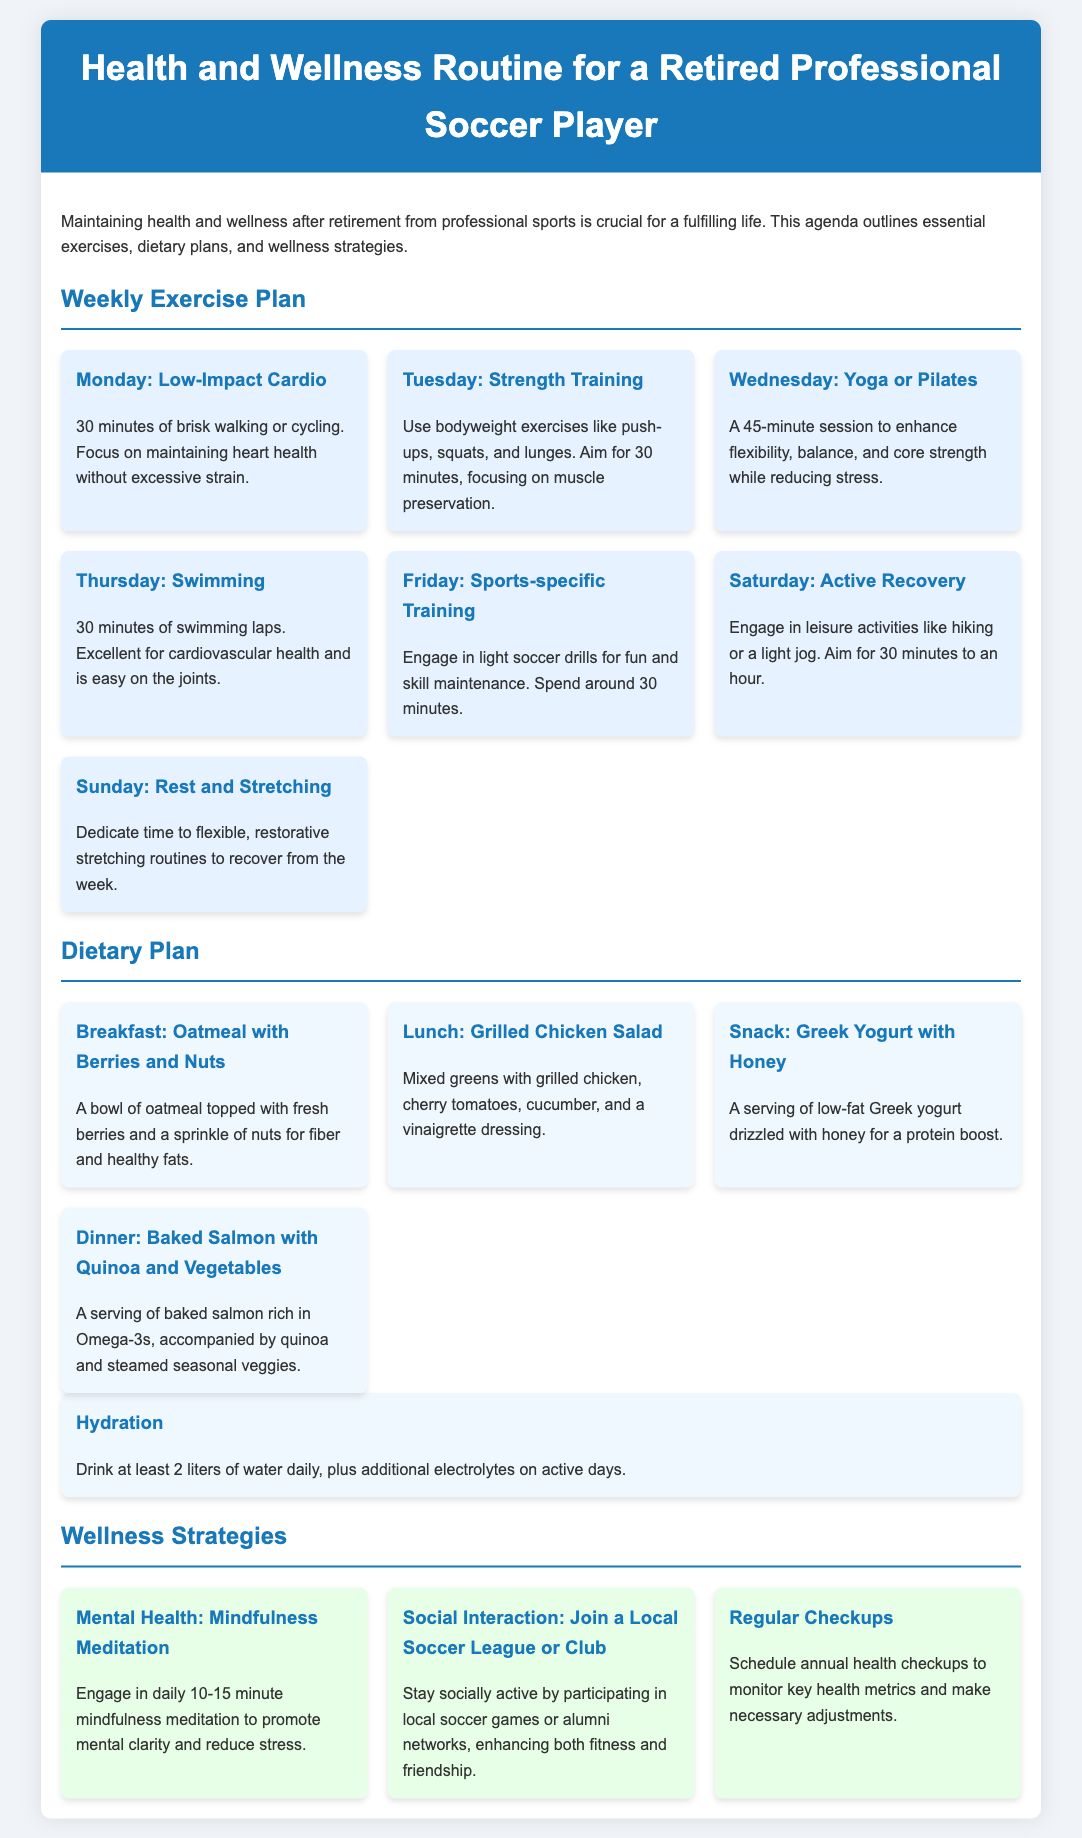what is the duration of the Monday exercise? The document states that the Monday exercise consists of 30 minutes of brisk walking or cycling.
Answer: 30 minutes what type of training is scheduled for Tuesday? The Tuesday session involves strength training with bodyweight exercises like push-ups, squats, and lunges.
Answer: Strength Training how long is the Wednesday yoga session? The document specifies a 45-minute session for yoga or Pilates.
Answer: 45 minutes what is included in the breakfast dietary plan? The breakfast consists of oatmeal topped with fresh berries and a sprinkle of nuts.
Answer: Oatmeal with Berries and Nuts what exercise is recommended for Thursday? The exercise recommended for Thursday is swimming.
Answer: Swimming what is the main focus of the wellness strategy for mental health? The strategy emphasizes daily mindfulness meditation for mental clarity and stress reduction.
Answer: Mindfulness Meditation how many liters of water should be consumed daily? The document recommends drinking at least 2 liters of water daily.
Answer: 2 liters which day is designated for rest and stretching? The Sunday session is dedicated to rest and stretching routines.
Answer: Sunday how does the document suggest staying socially active? It suggests joining a local soccer league or club for social interaction.
Answer: Local soccer league or club 